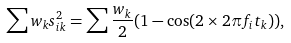Convert formula to latex. <formula><loc_0><loc_0><loc_500><loc_500>\sum w _ { k } s _ { i k } ^ { 2 } = \sum \frac { w _ { k } } { 2 } ( 1 - \cos ( 2 \times 2 \pi f _ { i } t _ { k } ) ) ,</formula> 